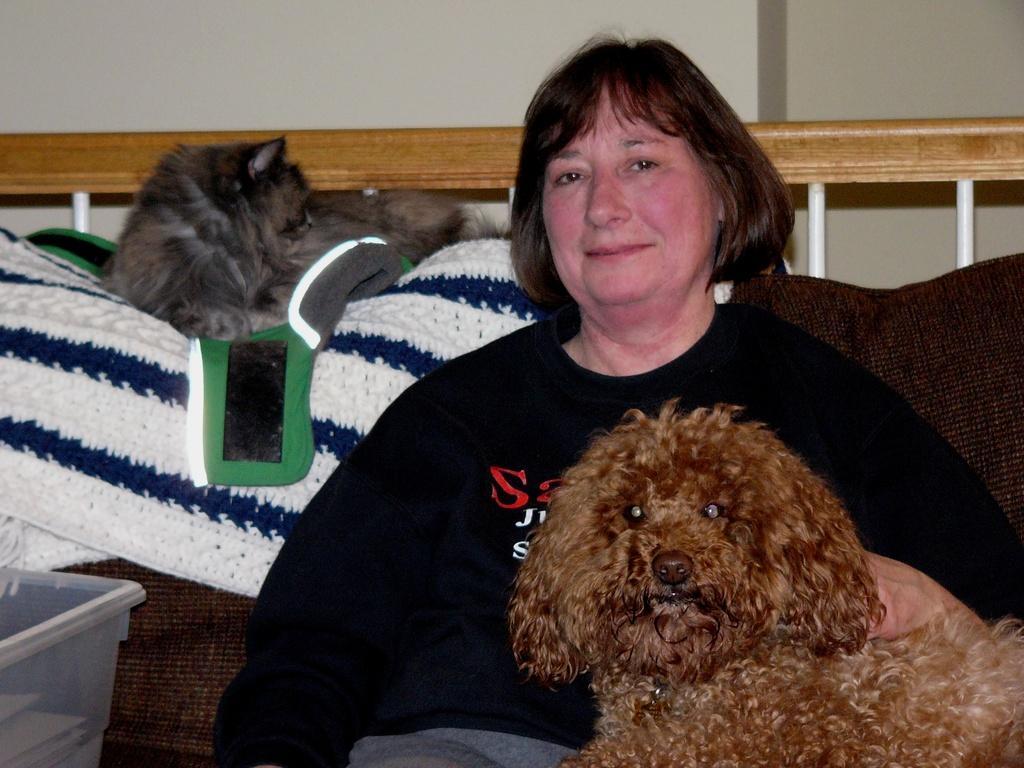In one or two sentences, can you explain what this image depicts? In this picture we can see one woman sitting on the couch and she is holding a dog, behind we can see a dog on the blanket. 